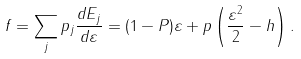Convert formula to latex. <formula><loc_0><loc_0><loc_500><loc_500>f = \sum _ { j } p _ { j } \frac { d E _ { j } } { d \varepsilon } = ( 1 - P ) \varepsilon + p \left ( \frac { \varepsilon ^ { 2 } } { 2 } - h \right ) .</formula> 